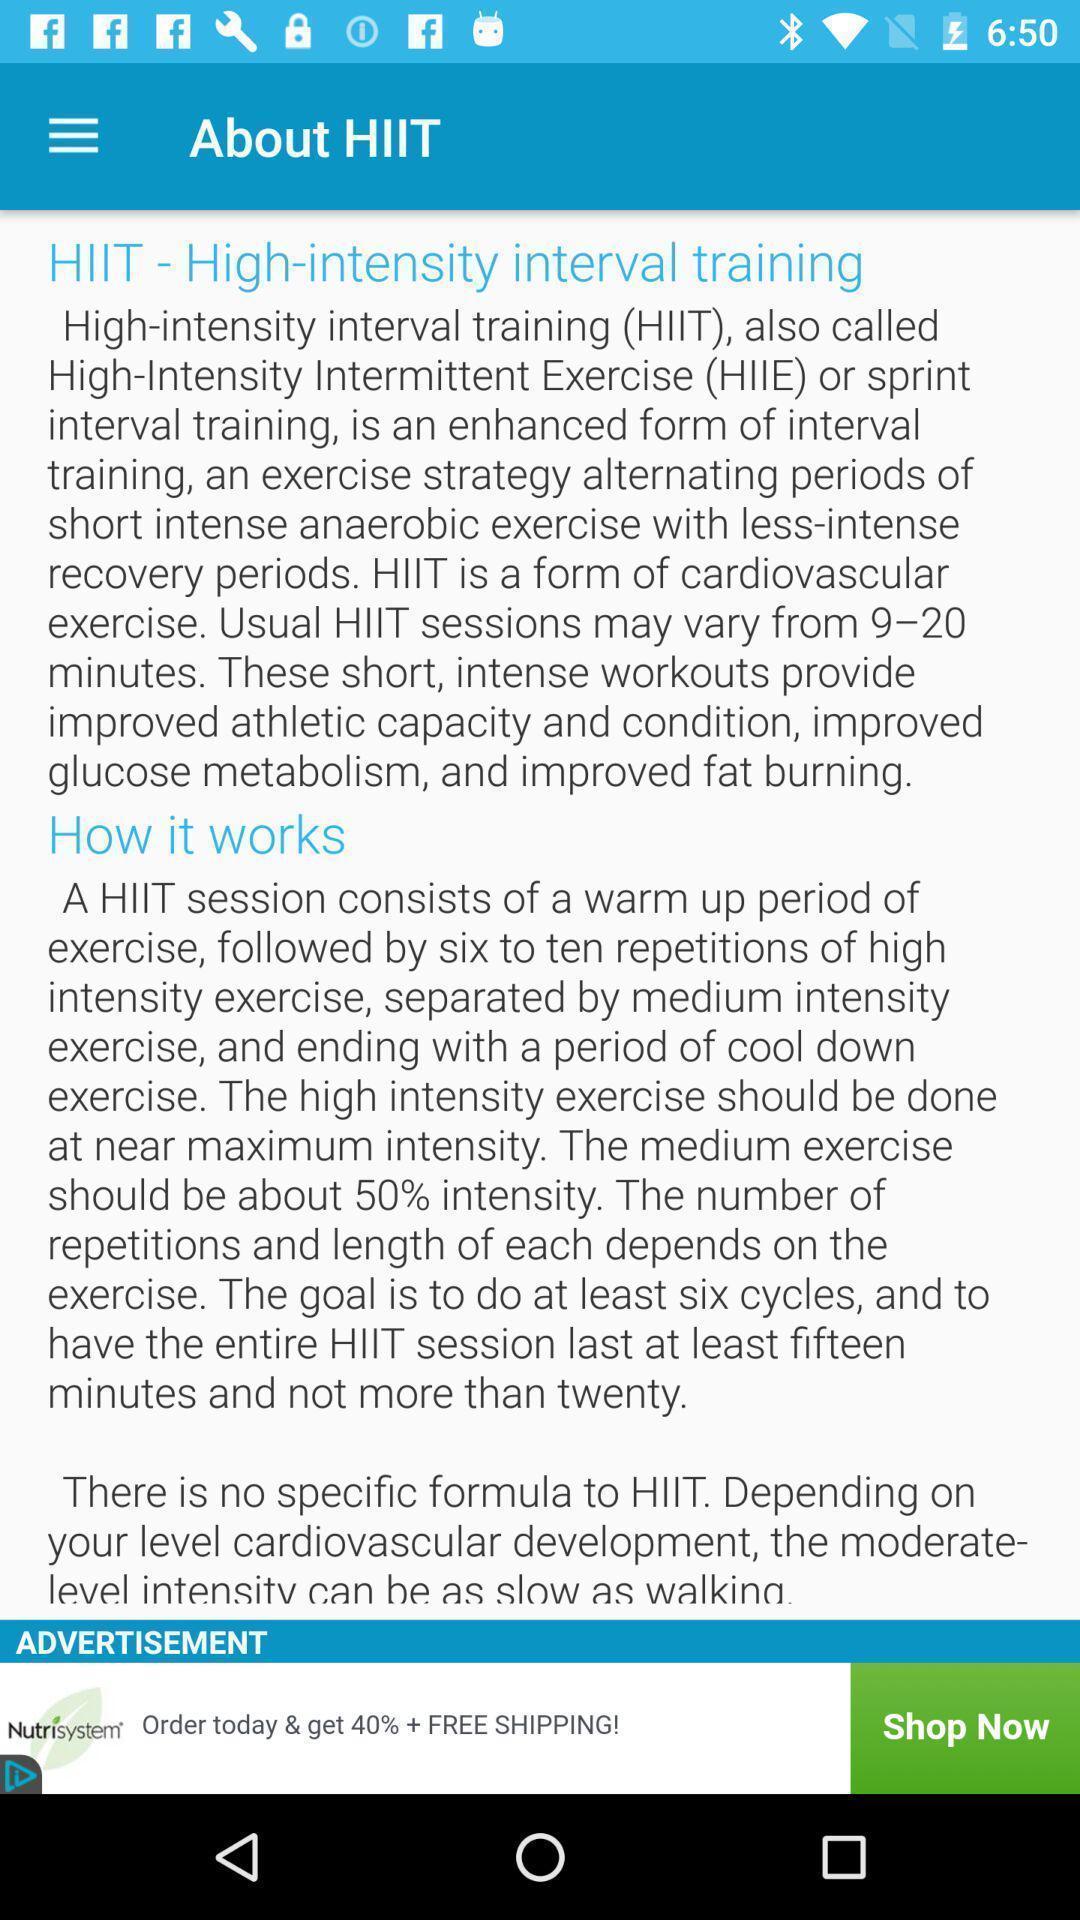What can you discern from this picture? Screen displaying about. 